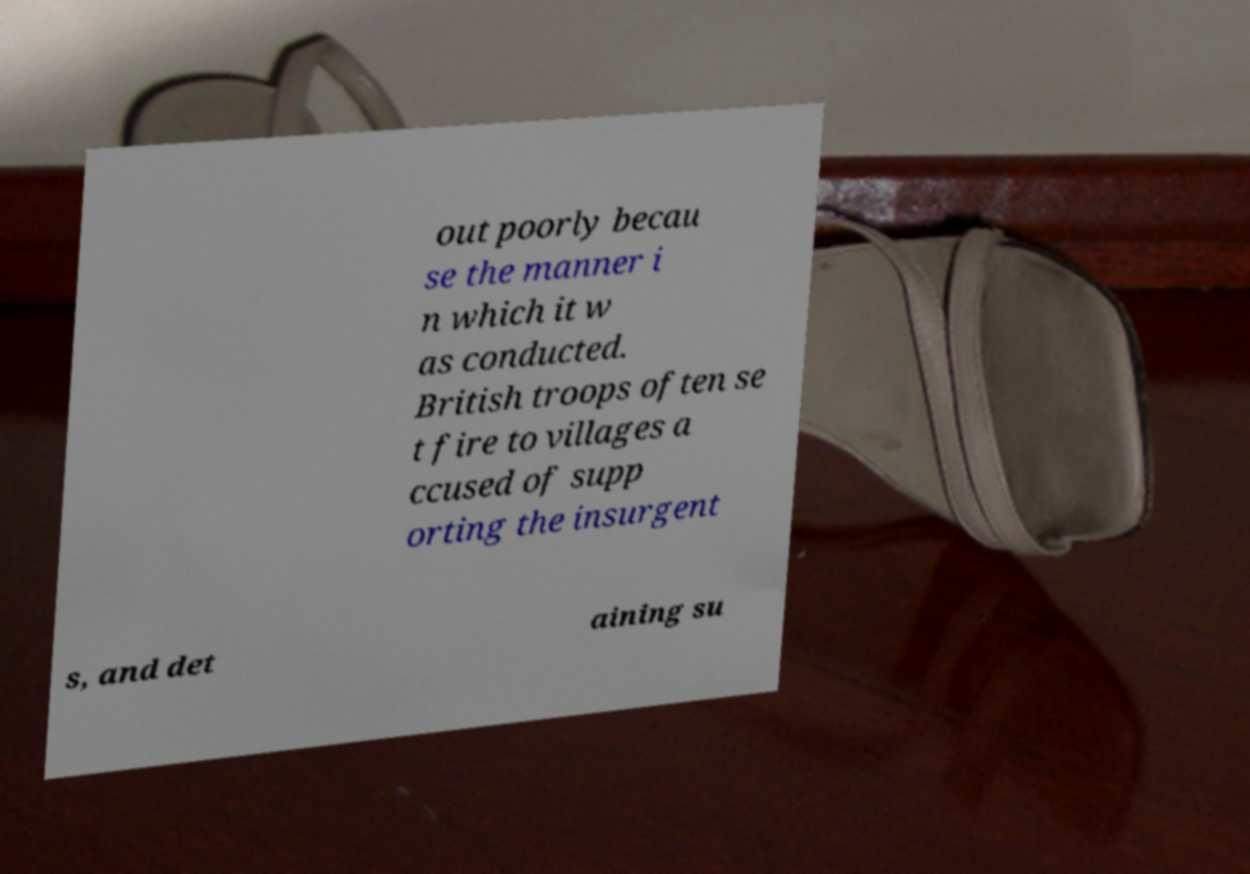Could you assist in decoding the text presented in this image and type it out clearly? out poorly becau se the manner i n which it w as conducted. British troops often se t fire to villages a ccused of supp orting the insurgent s, and det aining su 